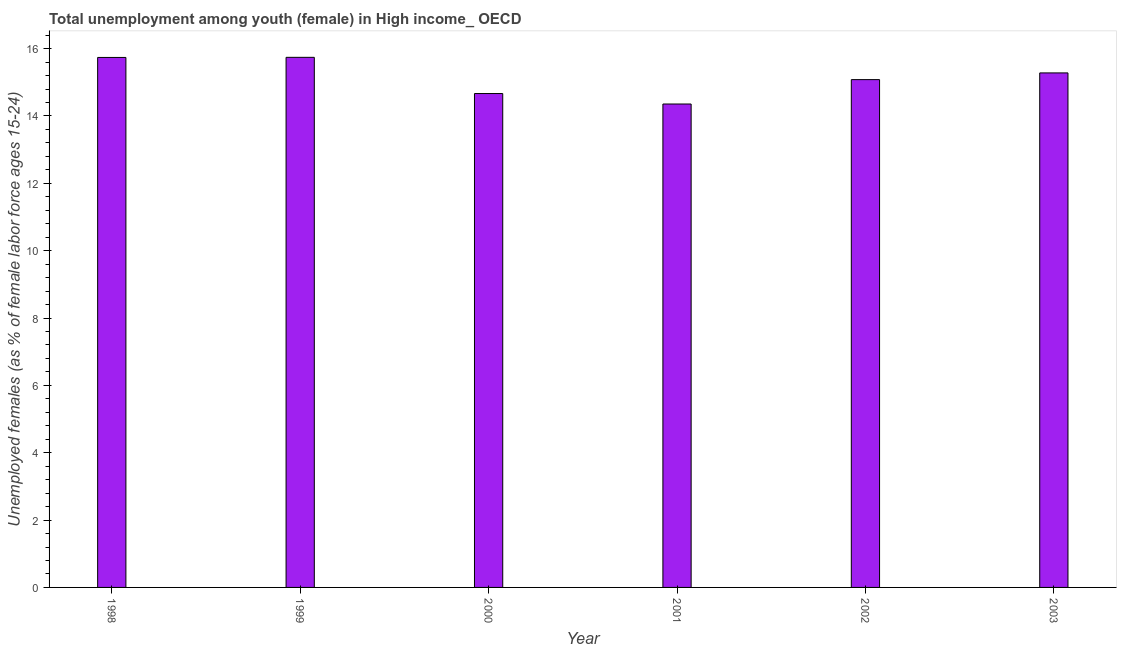What is the title of the graph?
Offer a terse response. Total unemployment among youth (female) in High income_ OECD. What is the label or title of the Y-axis?
Your response must be concise. Unemployed females (as % of female labor force ages 15-24). What is the unemployed female youth population in 2002?
Make the answer very short. 15.08. Across all years, what is the maximum unemployed female youth population?
Make the answer very short. 15.74. Across all years, what is the minimum unemployed female youth population?
Provide a succinct answer. 14.35. In which year was the unemployed female youth population minimum?
Your answer should be compact. 2001. What is the sum of the unemployed female youth population?
Your answer should be compact. 90.86. What is the difference between the unemployed female youth population in 2000 and 2003?
Give a very brief answer. -0.61. What is the average unemployed female youth population per year?
Offer a very short reply. 15.14. What is the median unemployed female youth population?
Your answer should be compact. 15.18. In how many years, is the unemployed female youth population greater than 2.4 %?
Your response must be concise. 6. Do a majority of the years between 2002 and 2000 (inclusive) have unemployed female youth population greater than 15.6 %?
Provide a short and direct response. Yes. What is the ratio of the unemployed female youth population in 1999 to that in 2001?
Offer a very short reply. 1.1. What is the difference between the highest and the second highest unemployed female youth population?
Keep it short and to the point. 0. What is the difference between the highest and the lowest unemployed female youth population?
Give a very brief answer. 1.39. In how many years, is the unemployed female youth population greater than the average unemployed female youth population taken over all years?
Offer a terse response. 3. How many years are there in the graph?
Your answer should be compact. 6. What is the Unemployed females (as % of female labor force ages 15-24) in 1998?
Provide a short and direct response. 15.74. What is the Unemployed females (as % of female labor force ages 15-24) in 1999?
Offer a terse response. 15.74. What is the Unemployed females (as % of female labor force ages 15-24) in 2000?
Your answer should be very brief. 14.67. What is the Unemployed females (as % of female labor force ages 15-24) in 2001?
Give a very brief answer. 14.35. What is the Unemployed females (as % of female labor force ages 15-24) in 2002?
Your response must be concise. 15.08. What is the Unemployed females (as % of female labor force ages 15-24) in 2003?
Your answer should be compact. 15.28. What is the difference between the Unemployed females (as % of female labor force ages 15-24) in 1998 and 1999?
Provide a short and direct response. -0. What is the difference between the Unemployed females (as % of female labor force ages 15-24) in 1998 and 2000?
Your response must be concise. 1.07. What is the difference between the Unemployed females (as % of female labor force ages 15-24) in 1998 and 2001?
Keep it short and to the point. 1.38. What is the difference between the Unemployed females (as % of female labor force ages 15-24) in 1998 and 2002?
Offer a terse response. 0.66. What is the difference between the Unemployed females (as % of female labor force ages 15-24) in 1998 and 2003?
Offer a very short reply. 0.46. What is the difference between the Unemployed females (as % of female labor force ages 15-24) in 1999 and 2000?
Offer a terse response. 1.07. What is the difference between the Unemployed females (as % of female labor force ages 15-24) in 1999 and 2001?
Your answer should be compact. 1.39. What is the difference between the Unemployed females (as % of female labor force ages 15-24) in 1999 and 2002?
Make the answer very short. 0.66. What is the difference between the Unemployed females (as % of female labor force ages 15-24) in 1999 and 2003?
Give a very brief answer. 0.46. What is the difference between the Unemployed females (as % of female labor force ages 15-24) in 2000 and 2001?
Keep it short and to the point. 0.31. What is the difference between the Unemployed females (as % of female labor force ages 15-24) in 2000 and 2002?
Your answer should be very brief. -0.41. What is the difference between the Unemployed females (as % of female labor force ages 15-24) in 2000 and 2003?
Your response must be concise. -0.61. What is the difference between the Unemployed females (as % of female labor force ages 15-24) in 2001 and 2002?
Keep it short and to the point. -0.72. What is the difference between the Unemployed females (as % of female labor force ages 15-24) in 2001 and 2003?
Offer a very short reply. -0.92. What is the difference between the Unemployed females (as % of female labor force ages 15-24) in 2002 and 2003?
Make the answer very short. -0.2. What is the ratio of the Unemployed females (as % of female labor force ages 15-24) in 1998 to that in 1999?
Keep it short and to the point. 1. What is the ratio of the Unemployed females (as % of female labor force ages 15-24) in 1998 to that in 2000?
Your answer should be compact. 1.07. What is the ratio of the Unemployed females (as % of female labor force ages 15-24) in 1998 to that in 2001?
Offer a terse response. 1.1. What is the ratio of the Unemployed females (as % of female labor force ages 15-24) in 1998 to that in 2002?
Offer a very short reply. 1.04. What is the ratio of the Unemployed females (as % of female labor force ages 15-24) in 1999 to that in 2000?
Offer a terse response. 1.07. What is the ratio of the Unemployed females (as % of female labor force ages 15-24) in 1999 to that in 2001?
Provide a succinct answer. 1.1. What is the ratio of the Unemployed females (as % of female labor force ages 15-24) in 1999 to that in 2002?
Your answer should be very brief. 1.04. What is the ratio of the Unemployed females (as % of female labor force ages 15-24) in 2001 to that in 2003?
Provide a succinct answer. 0.94. 